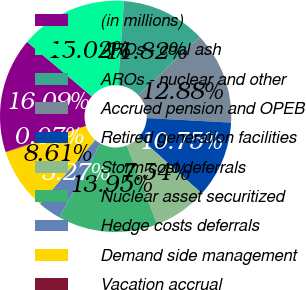<chart> <loc_0><loc_0><loc_500><loc_500><pie_chart><fcel>(in millions)<fcel>AROs - coal ash<fcel>AROs - nuclear and other<fcel>Accrued pension and OPEB<fcel>Retired generation facilities<fcel>Storm cost deferrals<fcel>Nuclear asset securitized<fcel>Hedge costs deferrals<fcel>Demand side management<fcel>Vacation accrual<nl><fcel>16.09%<fcel>15.02%<fcel>11.82%<fcel>12.88%<fcel>10.75%<fcel>7.54%<fcel>13.95%<fcel>3.27%<fcel>8.61%<fcel>0.07%<nl></chart> 